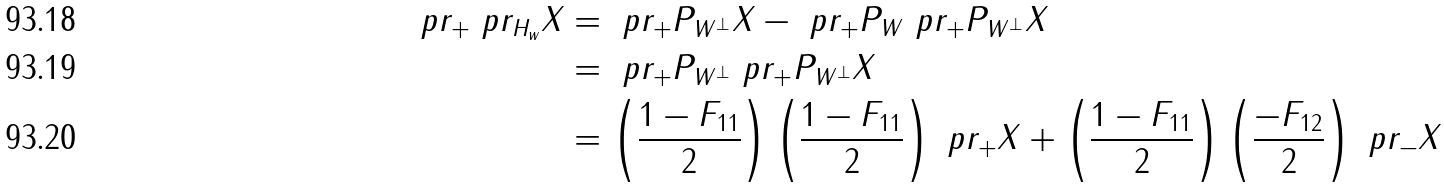<formula> <loc_0><loc_0><loc_500><loc_500>\ p r _ { + } \ p r _ { H _ { w } } X & = \ p r _ { + } P _ { W ^ { \perp } } X - \ p r _ { + } P _ { W } \ p r _ { + } P _ { W ^ { \perp } } X \\ & = \ p r _ { + } P _ { W ^ { \perp } } \ p r _ { + } P _ { W ^ { \perp } } X \\ & = \left ( \frac { 1 - F _ { 1 1 } } { 2 } \right ) \left ( \frac { 1 - F _ { 1 1 } } { 2 } \right ) \ p r _ { + } X + \left ( \frac { 1 - F _ { 1 1 } } { 2 } \right ) \left ( \frac { - F _ { 1 2 } } { 2 } \right ) \ p r _ { - } X</formula> 